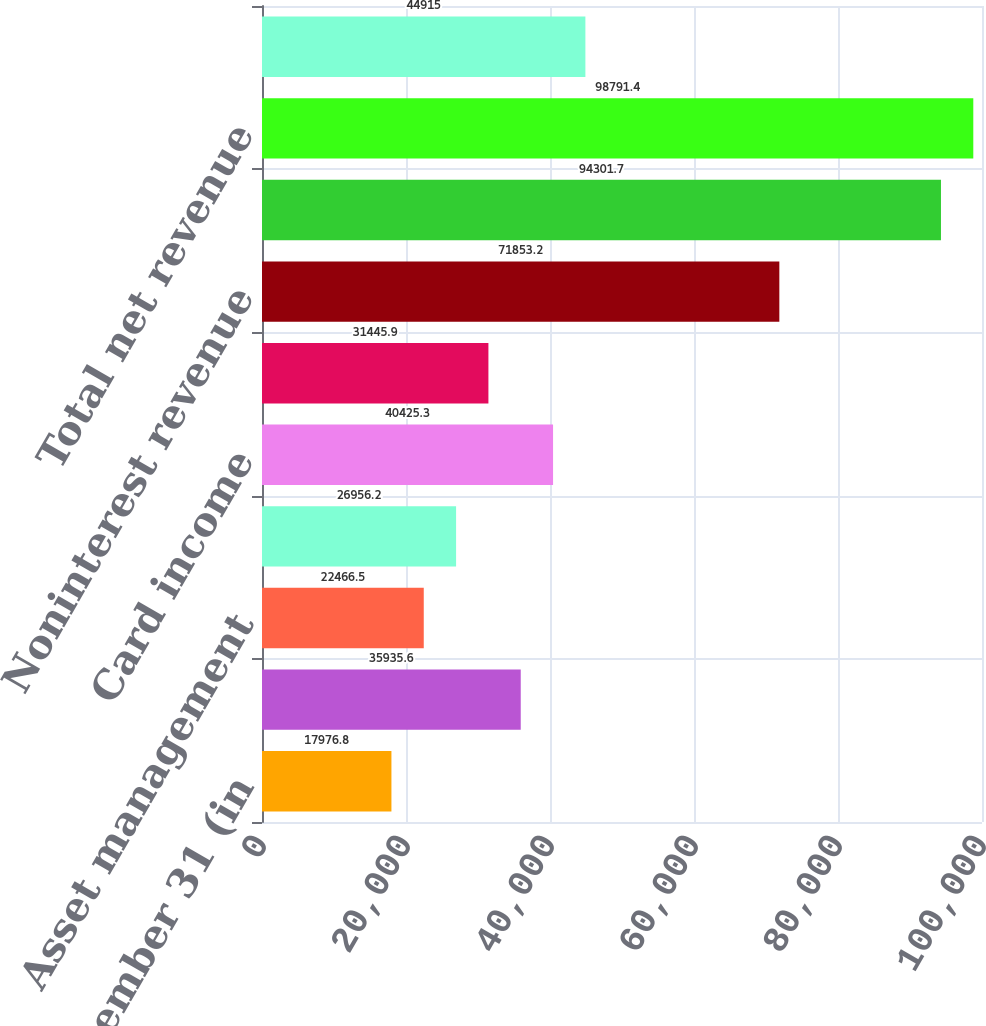Convert chart to OTSL. <chart><loc_0><loc_0><loc_500><loc_500><bar_chart><fcel>Year ended December 31 (in<fcel>Lending- and deposit-related<fcel>Asset management<fcel>Mortgage fees and related<fcel>Card income<fcel>All other income<fcel>Noninterest revenue<fcel>Net interest income<fcel>Total net revenue<fcel>Provision for credit losses<nl><fcel>17976.8<fcel>35935.6<fcel>22466.5<fcel>26956.2<fcel>40425.3<fcel>31445.9<fcel>71853.2<fcel>94301.7<fcel>98791.4<fcel>44915<nl></chart> 